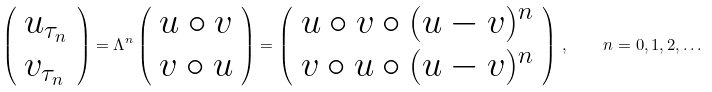<formula> <loc_0><loc_0><loc_500><loc_500>\left ( \begin{array} { l } u _ { \tau _ { n } } \\ v _ { \tau _ { n } } \end{array} \right ) = \Lambda ^ { n } \left ( \begin{array} { l } u \circ v \\ v \circ u \end{array} \right ) = \left ( \begin{array} { l } u \circ v \circ ( u - v ) ^ { n } \\ v \circ u \circ ( u - v ) ^ { n } \end{array} \right ) \, , \quad n = 0 , 1 , 2 , \dots</formula> 